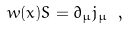Convert formula to latex. <formula><loc_0><loc_0><loc_500><loc_500>w ( x ) S = \partial _ { \mu } j _ { \mu } \ ,</formula> 